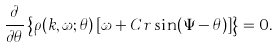Convert formula to latex. <formula><loc_0><loc_0><loc_500><loc_500>\frac { \partial } { \partial \theta } \left \{ \rho ( k , \omega ; \theta ) \left [ \omega + C r \sin ( \Psi - \theta ) \right ] \right \} = 0 .</formula> 